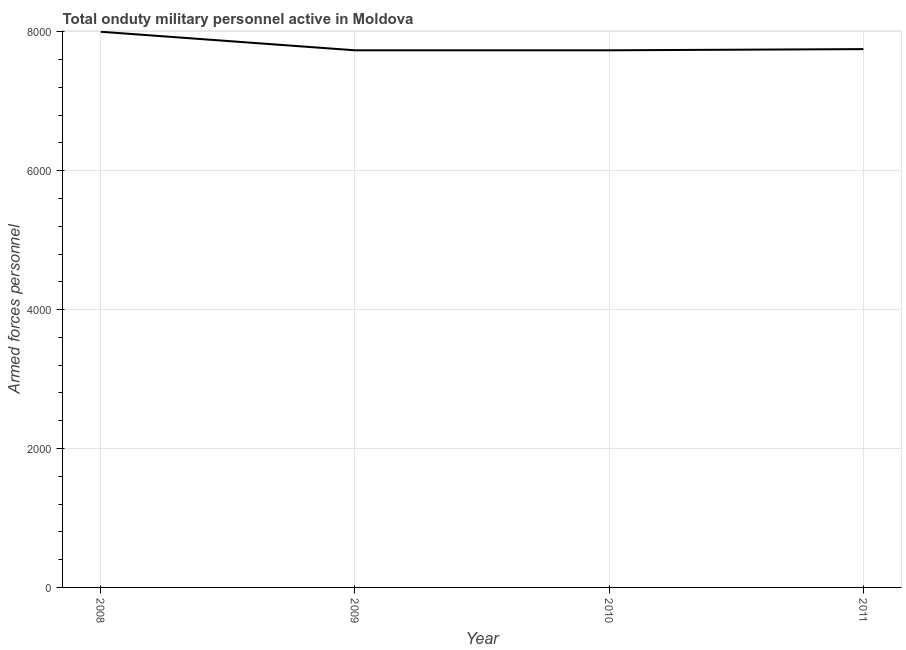What is the number of armed forces personnel in 2011?
Your response must be concise. 7750. Across all years, what is the maximum number of armed forces personnel?
Ensure brevity in your answer.  8000. Across all years, what is the minimum number of armed forces personnel?
Provide a succinct answer. 7733. In which year was the number of armed forces personnel minimum?
Your answer should be very brief. 2009. What is the sum of the number of armed forces personnel?
Make the answer very short. 3.12e+04. What is the difference between the number of armed forces personnel in 2008 and 2010?
Ensure brevity in your answer.  267. What is the average number of armed forces personnel per year?
Make the answer very short. 7804. What is the median number of armed forces personnel?
Provide a succinct answer. 7741.5. In how many years, is the number of armed forces personnel greater than 4800 ?
Your response must be concise. 4. What is the ratio of the number of armed forces personnel in 2008 to that in 2011?
Ensure brevity in your answer.  1.03. What is the difference between the highest and the second highest number of armed forces personnel?
Your response must be concise. 250. What is the difference between the highest and the lowest number of armed forces personnel?
Keep it short and to the point. 267. In how many years, is the number of armed forces personnel greater than the average number of armed forces personnel taken over all years?
Your answer should be very brief. 1. Does the number of armed forces personnel monotonically increase over the years?
Your answer should be compact. No. Does the graph contain any zero values?
Ensure brevity in your answer.  No. What is the title of the graph?
Make the answer very short. Total onduty military personnel active in Moldova. What is the label or title of the Y-axis?
Provide a succinct answer. Armed forces personnel. What is the Armed forces personnel of 2008?
Give a very brief answer. 8000. What is the Armed forces personnel of 2009?
Make the answer very short. 7733. What is the Armed forces personnel in 2010?
Provide a short and direct response. 7733. What is the Armed forces personnel in 2011?
Keep it short and to the point. 7750. What is the difference between the Armed forces personnel in 2008 and 2009?
Provide a short and direct response. 267. What is the difference between the Armed forces personnel in 2008 and 2010?
Your answer should be compact. 267. What is the difference between the Armed forces personnel in 2008 and 2011?
Offer a very short reply. 250. What is the difference between the Armed forces personnel in 2009 and 2010?
Your answer should be compact. 0. What is the difference between the Armed forces personnel in 2009 and 2011?
Your response must be concise. -17. What is the ratio of the Armed forces personnel in 2008 to that in 2009?
Provide a short and direct response. 1.03. What is the ratio of the Armed forces personnel in 2008 to that in 2010?
Make the answer very short. 1.03. What is the ratio of the Armed forces personnel in 2008 to that in 2011?
Give a very brief answer. 1.03. What is the ratio of the Armed forces personnel in 2009 to that in 2011?
Keep it short and to the point. 1. 